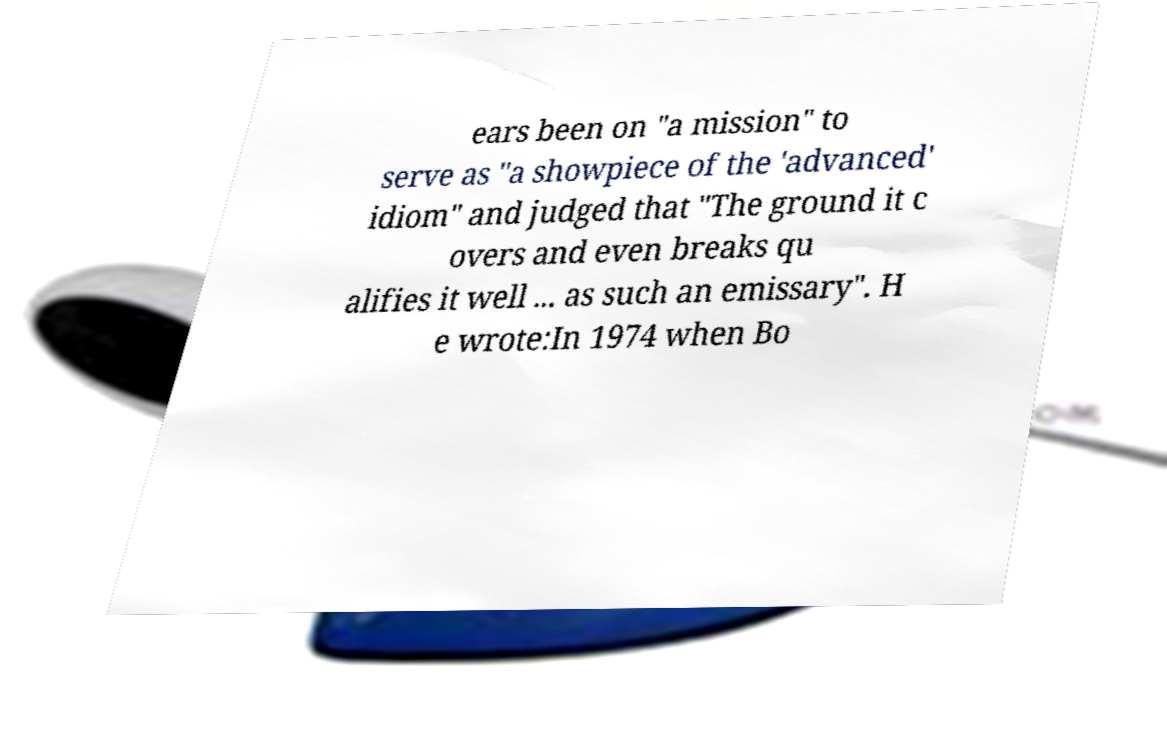I need the written content from this picture converted into text. Can you do that? ears been on "a mission" to serve as "a showpiece of the 'advanced' idiom" and judged that "The ground it c overs and even breaks qu alifies it well ... as such an emissary". H e wrote:In 1974 when Bo 